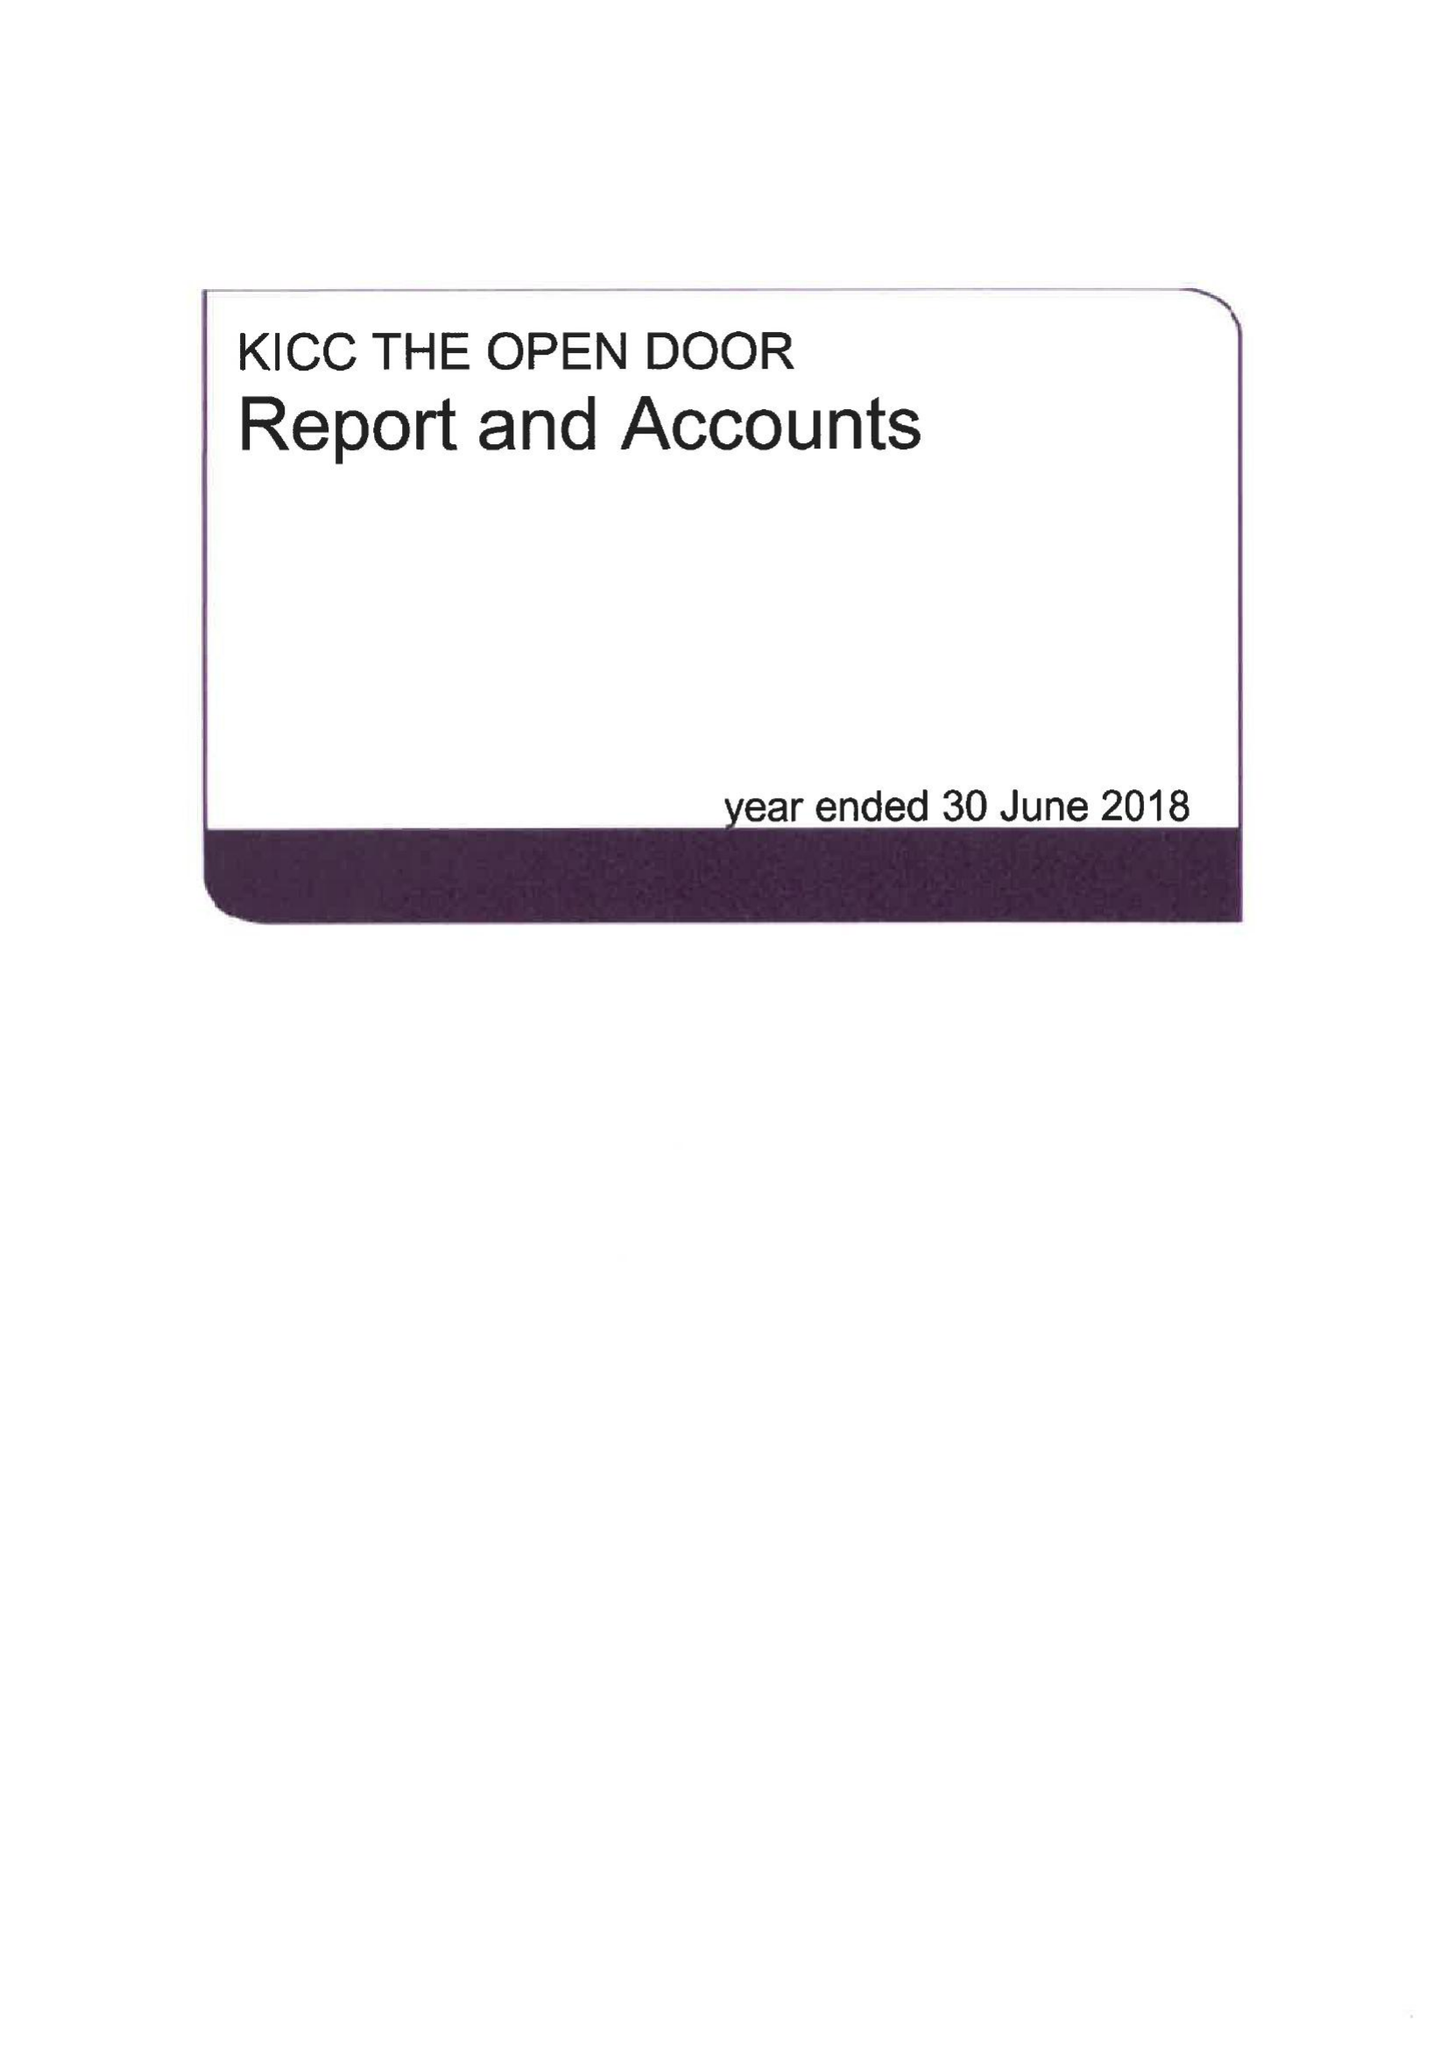What is the value for the spending_annually_in_british_pounds?
Answer the question using a single word or phrase. 433946.00 